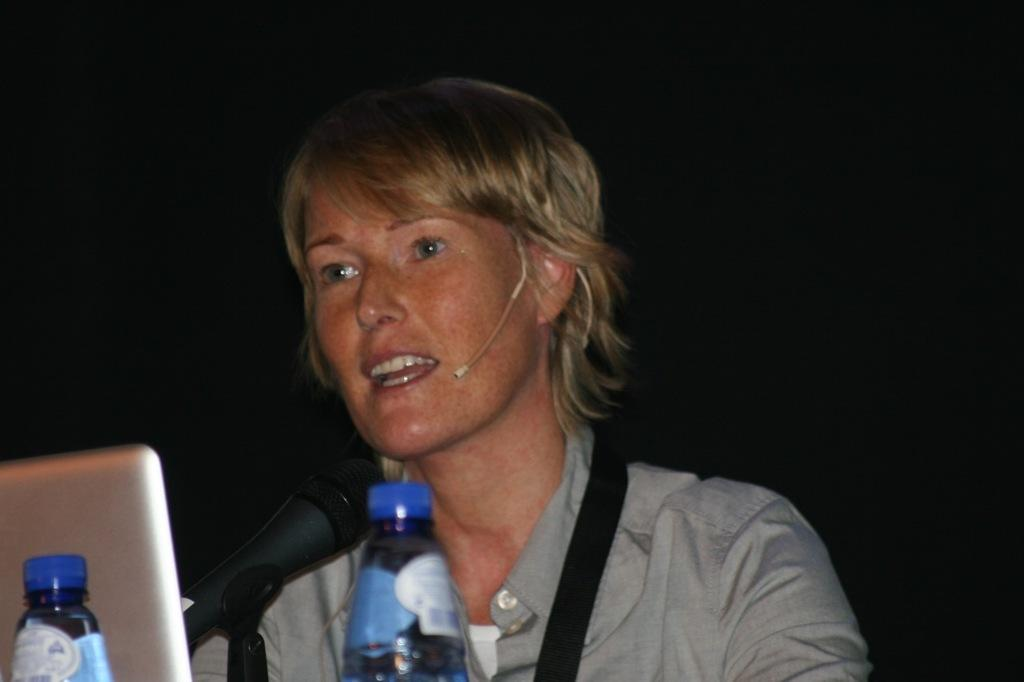Who is the main subject in the image? There is a woman in the image. What is the woman doing in the image? The woman is sitting in the center of the image and speaking on a microphone. What other objects can be seen in the image? There is a laptop and cool drink bottles present in the image. Where are the laptop and cool drink bottles located in the image? The laptop and cool drink bottles are on the left side of the image. What type of shoe is the woman wearing in the image? There is no information about the woman's shoes in the image, so we cannot determine the type of shoe she is wearing. 